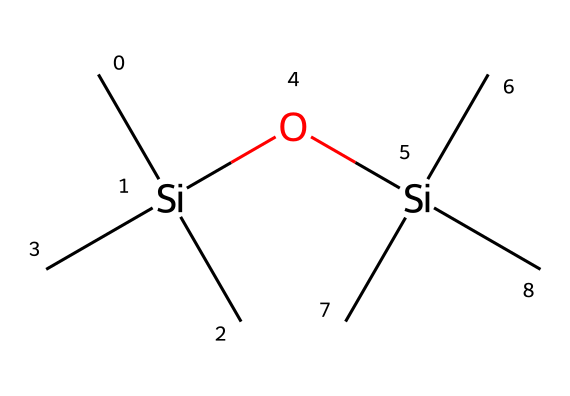What is the molecular formula of hexamethyldisiloxane? The chemical consists of 2 silicon (Si) atoms, 12 carbon (C) atoms, and 6 hydrogen (H) atoms, so the molecular formula can be derived as C12H36O2Si2.
Answer: C12H36O2Si2 How many silicon atoms are present in the structure? By analyzing the SMILES representation, we see two instances of "Si," indicating that there are two silicon atoms.
Answer: 2 What type of bond connects the silicon atoms? In this chemical structure, the silicon atoms are connected by an oxygen atom, forming a siloxane bond (Si-O-Si).
Answer: Siloxane How many oxygen atoms are in hexamethyldisiloxane? Counting the "O" in the SMILES notation shows that there is a single oxygen atom present in the structure.
Answer: 1 What type of compound is hexamethyldisiloxane classified as? The presence of silicon and carbon atoms embedded in a siloxane group confirms that this compound is classified as an organosilicon compound.
Answer: Organosilicon What is the primary role of hexamethyldisiloxane in aviation lubricants? Hexamethyldisiloxane provides lubrication, reduces friction, and enhances fluidity in aviation lubricants due to its volatile nature.
Answer: Lubrication What feature of this compound contributes to its volatility? The low molecular weight and the presence of simple, branched groups make it volatile, as observed in the linear structure and low boiling point of similar volatile silicones.
Answer: Low molecular weight 